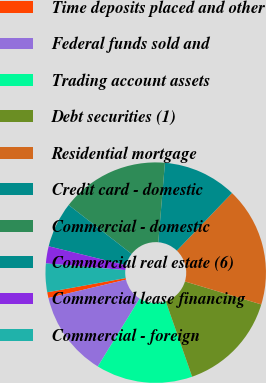Convert chart. <chart><loc_0><loc_0><loc_500><loc_500><pie_chart><fcel>Time deposits placed and other<fcel>Federal funds sold and<fcel>Trading account assets<fcel>Debt securities (1)<fcel>Residential mortgage<fcel>Credit card - domestic<fcel>Commercial - domestic<fcel>Commercial real estate (6)<fcel>Commercial lease financing<fcel>Commercial - foreign<nl><fcel>0.85%<fcel>12.5%<fcel>14.16%<fcel>14.99%<fcel>17.49%<fcel>10.83%<fcel>15.82%<fcel>6.67%<fcel>2.51%<fcel>4.18%<nl></chart> 